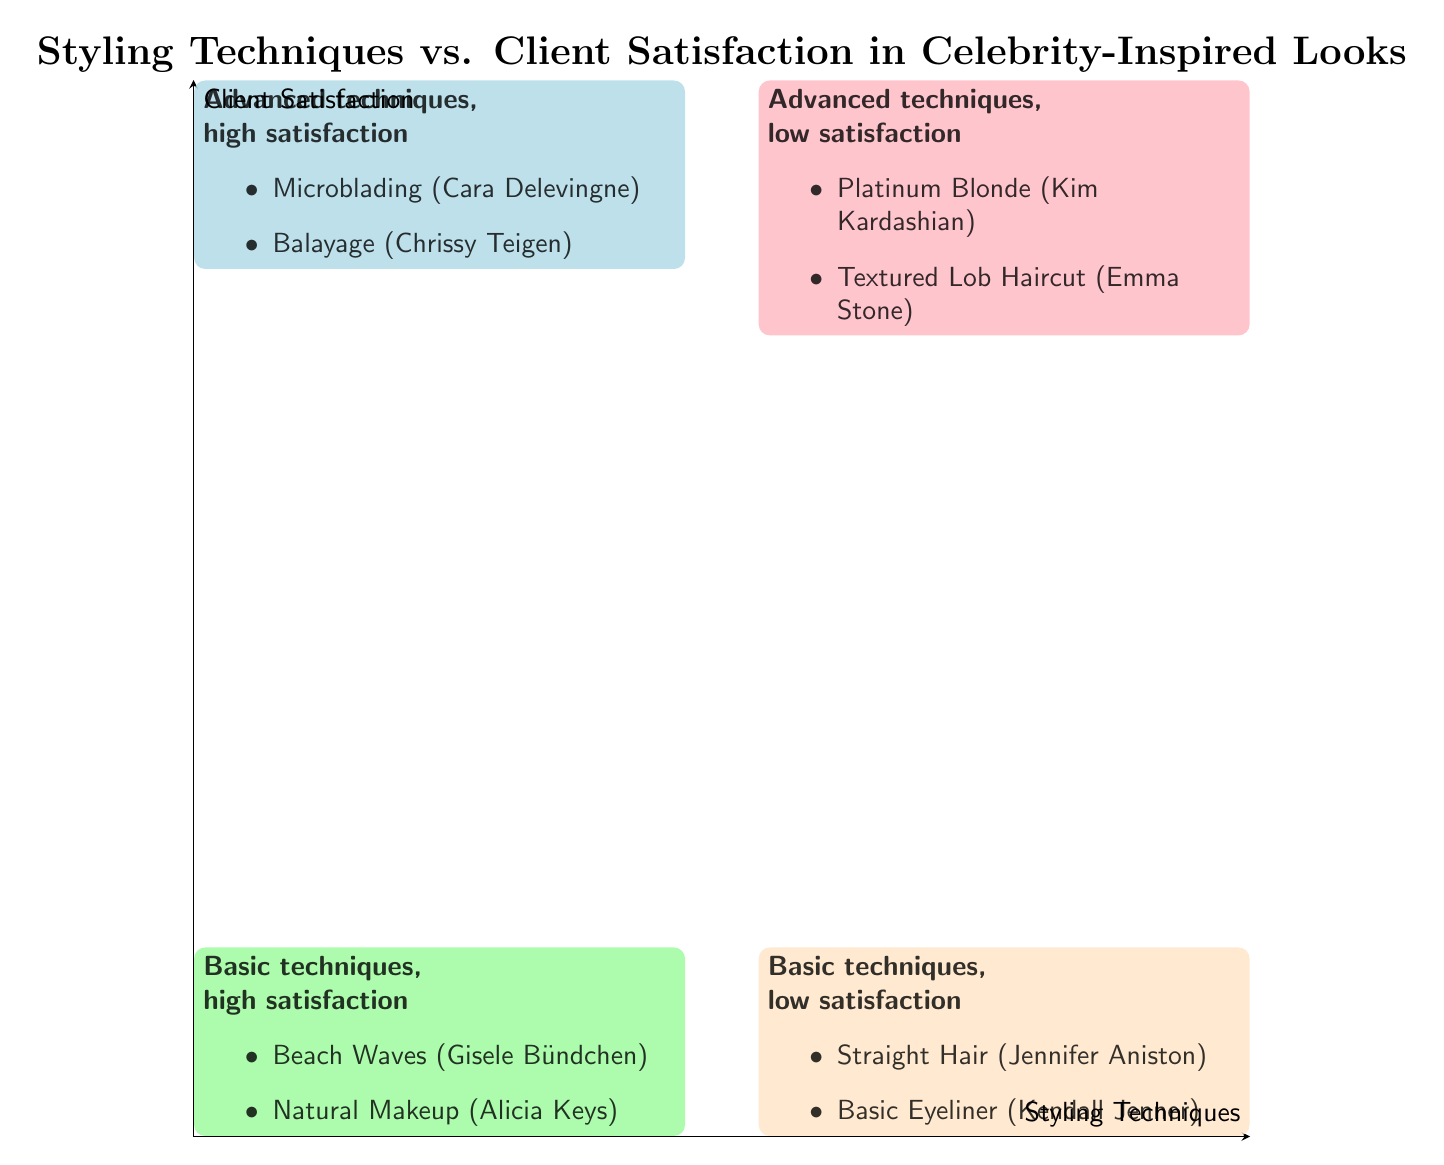What is the technique listed in the high technique, high satisfaction quadrant? In the diagram, the high technique, high satisfaction quadrant contains two examples, one of which is Microblading.
Answer: Microblading How many techniques are listed in the low satisfaction quadrants? The low satisfaction quadrants consist of two examples each: Platinum Blonde and Textured Lob Haircut in the high technique, low satisfaction quadrant, and Straight Hair and Basic Eyeliner in the low technique, low satisfaction quadrant. Therefore, there are a total of four techniques listed.
Answer: Four Which technique inspired by Cara Delevingne achieved high client satisfaction? Microblading, inspired by Cara Delevingne, is listed in the high technique, high satisfaction quadrant, therefore it indicates high client satisfaction.
Answer: Microblading In which quadrant can you find natural makeup, and what is the client feedback? Natural Makeup is located in the low technique, high satisfaction quadrant. The client feedback is that it enhances natural beauty.
Answer: Low technique, high satisfaction; enhances natural beauty What is the relationship between "Platinum Blonde" and "Textured Lob Haircut"? Both techniques are examples found in the high technique, low satisfaction quadrant, implying they share the same level of technique and low client satisfaction.
Answer: High technique, low satisfaction Which quadrant has the technique "Beach Waves"? The technique "Beach Waves" is classified within the low technique, high satisfaction quadrant according to the diagram.
Answer: Low technique, high satisfaction What type of client feedback is associated with the "Straight Hair" technique? "Straight Hair," which is in the low technique, low satisfaction quadrant, receives feedback indicating it lacks volume and feels too plain.
Answer: Lacks volume, feels too plain What can be inferred about the effectiveness of basic techniques in styling? Basic techniques (like Beach Waves and Natural Makeup) are associated with high client satisfaction, suggesting they are effective compared to advanced techniques with low satisfaction.
Answer: Effective Which two techniques are examples of advanced techniques with low satisfaction? The advanced techniques that received low client satisfaction are "Platinum Blonde" and "Textured Lob Haircut."
Answer: Platinum Blonde, Textured Lob Haircut 